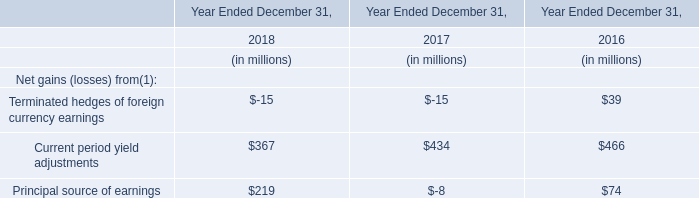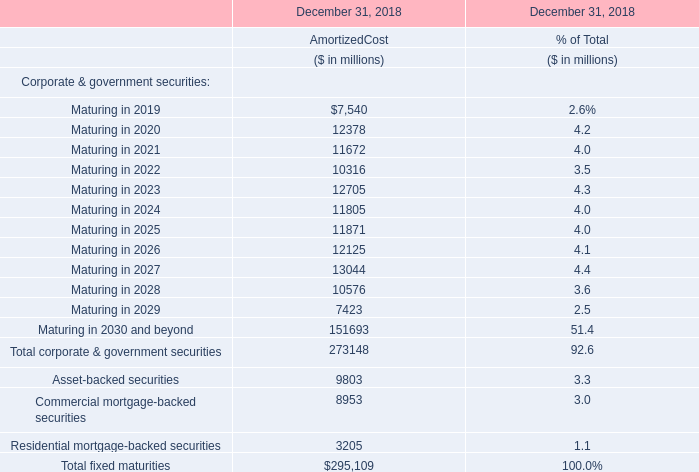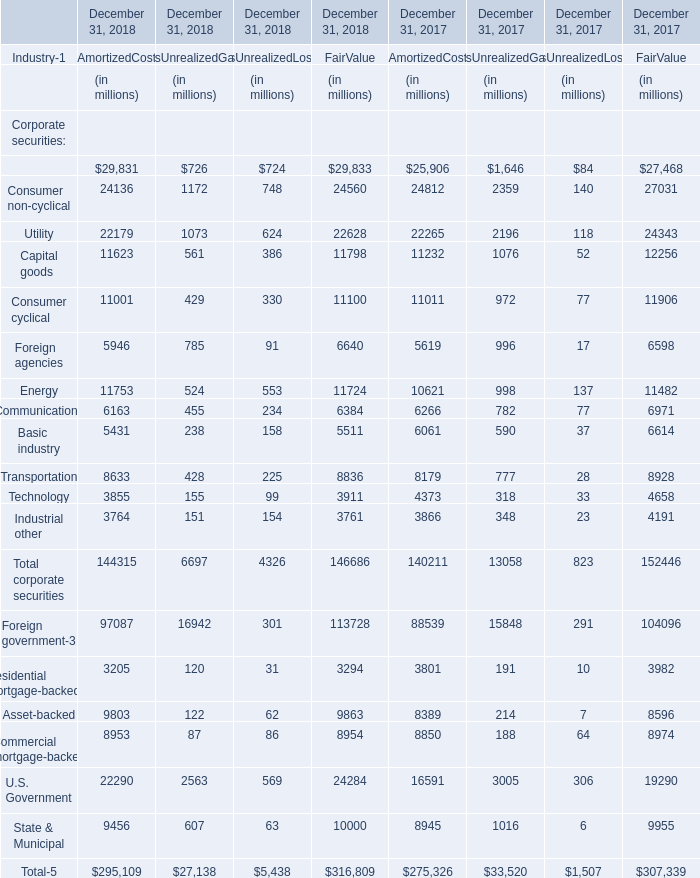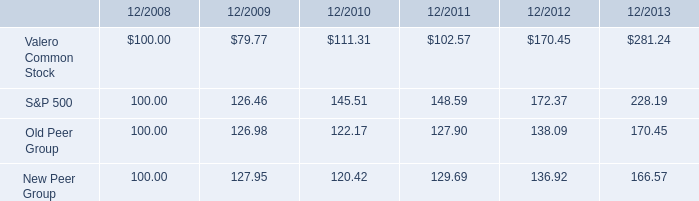What was the total amount of Maturing in 2020 and Maturing in 2021 in December 31, 2018 for AmortizedCost (in million) 
Computations: (12378 + 11672)
Answer: 24050.0. 